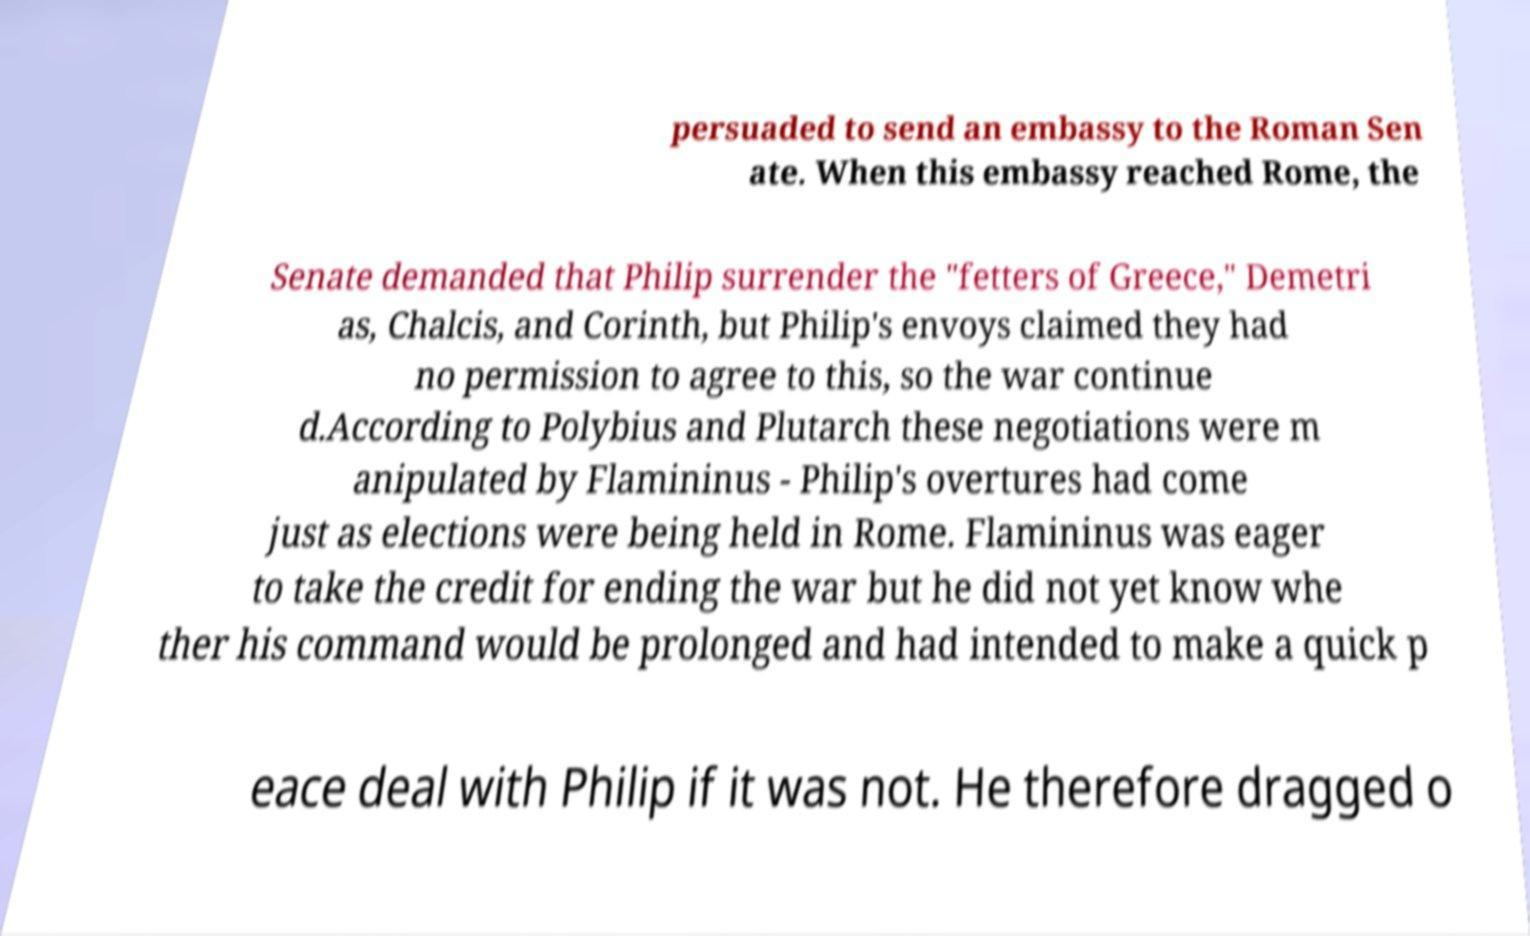Please identify and transcribe the text found in this image. persuaded to send an embassy to the Roman Sen ate. When this embassy reached Rome, the Senate demanded that Philip surrender the "fetters of Greece," Demetri as, Chalcis, and Corinth, but Philip's envoys claimed they had no permission to agree to this, so the war continue d.According to Polybius and Plutarch these negotiations were m anipulated by Flamininus - Philip's overtures had come just as elections were being held in Rome. Flamininus was eager to take the credit for ending the war but he did not yet know whe ther his command would be prolonged and had intended to make a quick p eace deal with Philip if it was not. He therefore dragged o 